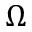Convert formula to latex. <formula><loc_0><loc_0><loc_500><loc_500>\Omega</formula> 